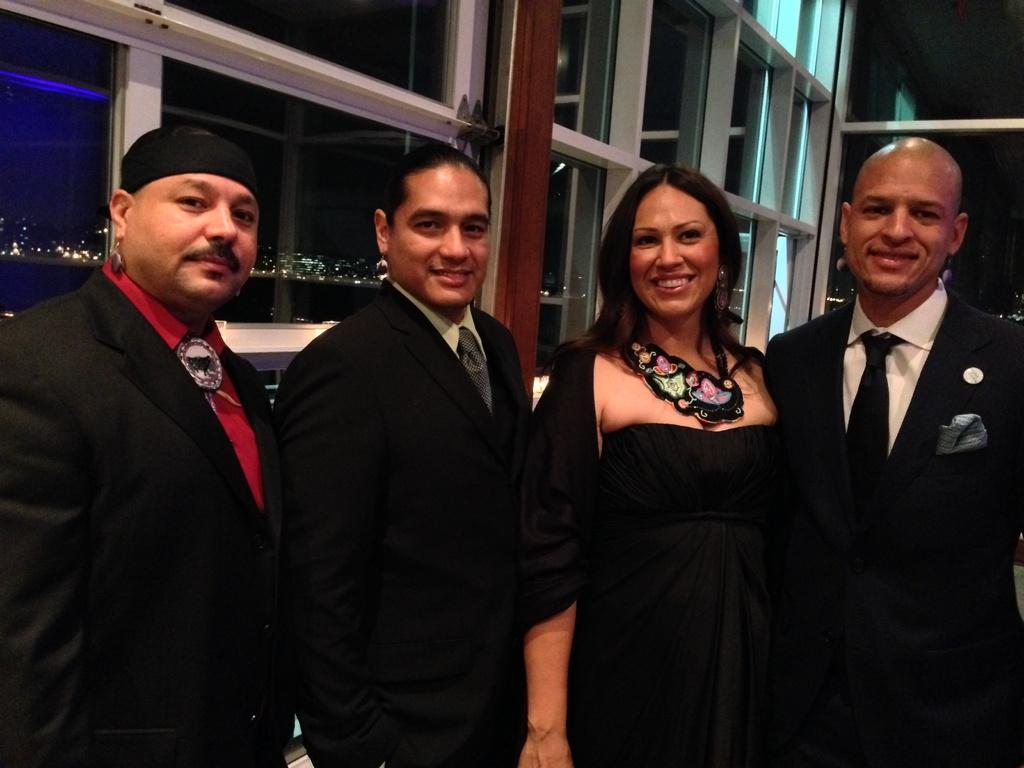Could you give a brief overview of what you see in this image? In this picture there is a woman who is wearing black dress, beside her there is a man who is wearing the suit. On the left there is a man who is wearing a red shirt and blazer. On the right there is a bald man who is wearing a suit. Everyone is smiling and they are standing near to the window. Through the window I can see the city, lights, buildings and water. 